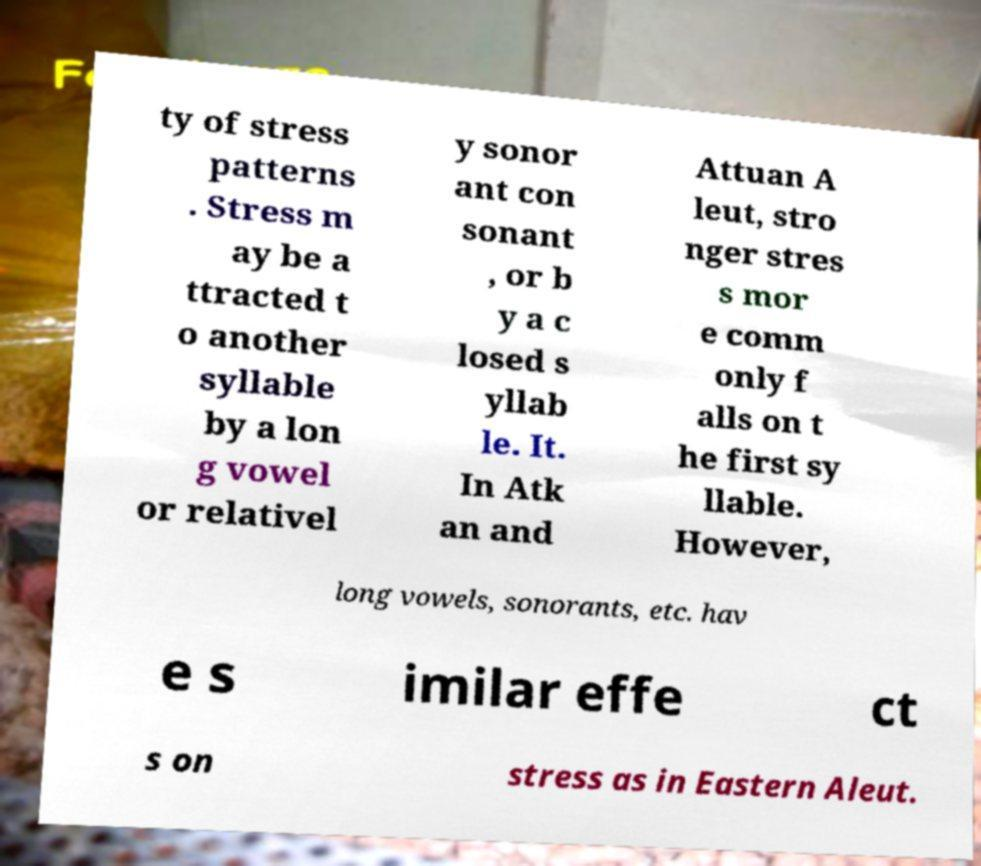What messages or text are displayed in this image? I need them in a readable, typed format. ty of stress patterns . Stress m ay be a ttracted t o another syllable by a lon g vowel or relativel y sonor ant con sonant , or b y a c losed s yllab le. It. In Atk an and Attuan A leut, stro nger stres s mor e comm only f alls on t he first sy llable. However, long vowels, sonorants, etc. hav e s imilar effe ct s on stress as in Eastern Aleut. 